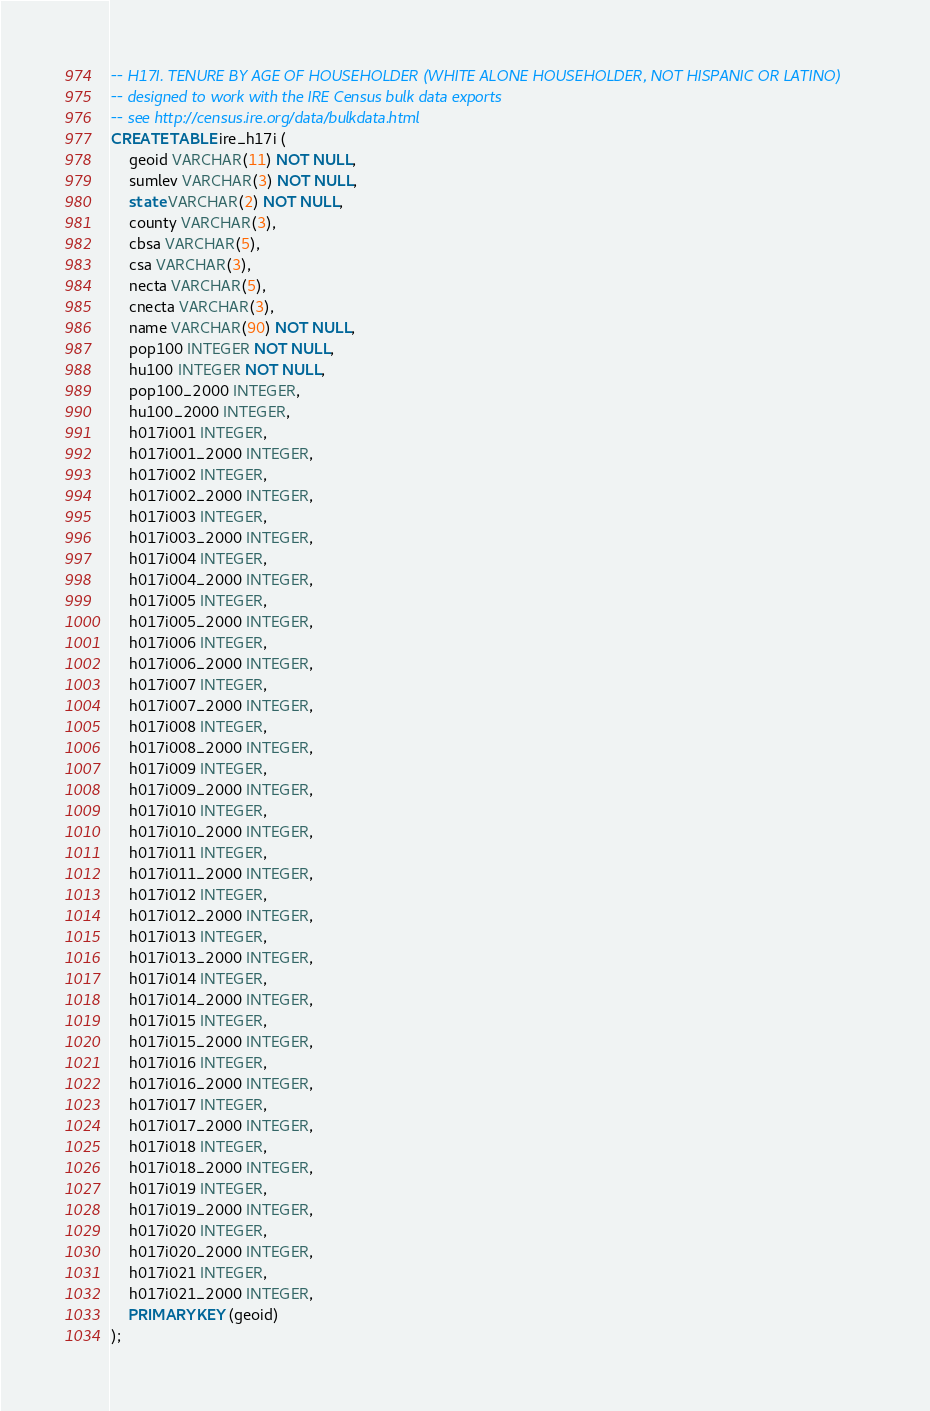<code> <loc_0><loc_0><loc_500><loc_500><_SQL_>-- H17I. TENURE BY AGE OF HOUSEHOLDER (WHITE ALONE HOUSEHOLDER, NOT HISPANIC OR LATINO)
-- designed to work with the IRE Census bulk data exports
-- see http://census.ire.org/data/bulkdata.html
CREATE TABLE ire_h17i (
	geoid VARCHAR(11) NOT NULL, 
	sumlev VARCHAR(3) NOT NULL, 
	state VARCHAR(2) NOT NULL, 
	county VARCHAR(3), 
	cbsa VARCHAR(5), 
	csa VARCHAR(3), 
	necta VARCHAR(5), 
	cnecta VARCHAR(3), 
	name VARCHAR(90) NOT NULL, 
	pop100 INTEGER NOT NULL, 
	hu100 INTEGER NOT NULL, 
	pop100_2000 INTEGER, 
	hu100_2000 INTEGER, 
	h017i001 INTEGER, 
	h017i001_2000 INTEGER, 
	h017i002 INTEGER, 
	h017i002_2000 INTEGER, 
	h017i003 INTEGER, 
	h017i003_2000 INTEGER, 
	h017i004 INTEGER, 
	h017i004_2000 INTEGER, 
	h017i005 INTEGER, 
	h017i005_2000 INTEGER, 
	h017i006 INTEGER, 
	h017i006_2000 INTEGER, 
	h017i007 INTEGER, 
	h017i007_2000 INTEGER, 
	h017i008 INTEGER, 
	h017i008_2000 INTEGER, 
	h017i009 INTEGER, 
	h017i009_2000 INTEGER, 
	h017i010 INTEGER, 
	h017i010_2000 INTEGER, 
	h017i011 INTEGER, 
	h017i011_2000 INTEGER, 
	h017i012 INTEGER, 
	h017i012_2000 INTEGER, 
	h017i013 INTEGER, 
	h017i013_2000 INTEGER, 
	h017i014 INTEGER, 
	h017i014_2000 INTEGER, 
	h017i015 INTEGER, 
	h017i015_2000 INTEGER, 
	h017i016 INTEGER, 
	h017i016_2000 INTEGER, 
	h017i017 INTEGER, 
	h017i017_2000 INTEGER, 
	h017i018 INTEGER, 
	h017i018_2000 INTEGER, 
	h017i019 INTEGER, 
	h017i019_2000 INTEGER, 
	h017i020 INTEGER, 
	h017i020_2000 INTEGER, 
	h017i021 INTEGER, 
	h017i021_2000 INTEGER, 
	PRIMARY KEY (geoid)
);
</code> 